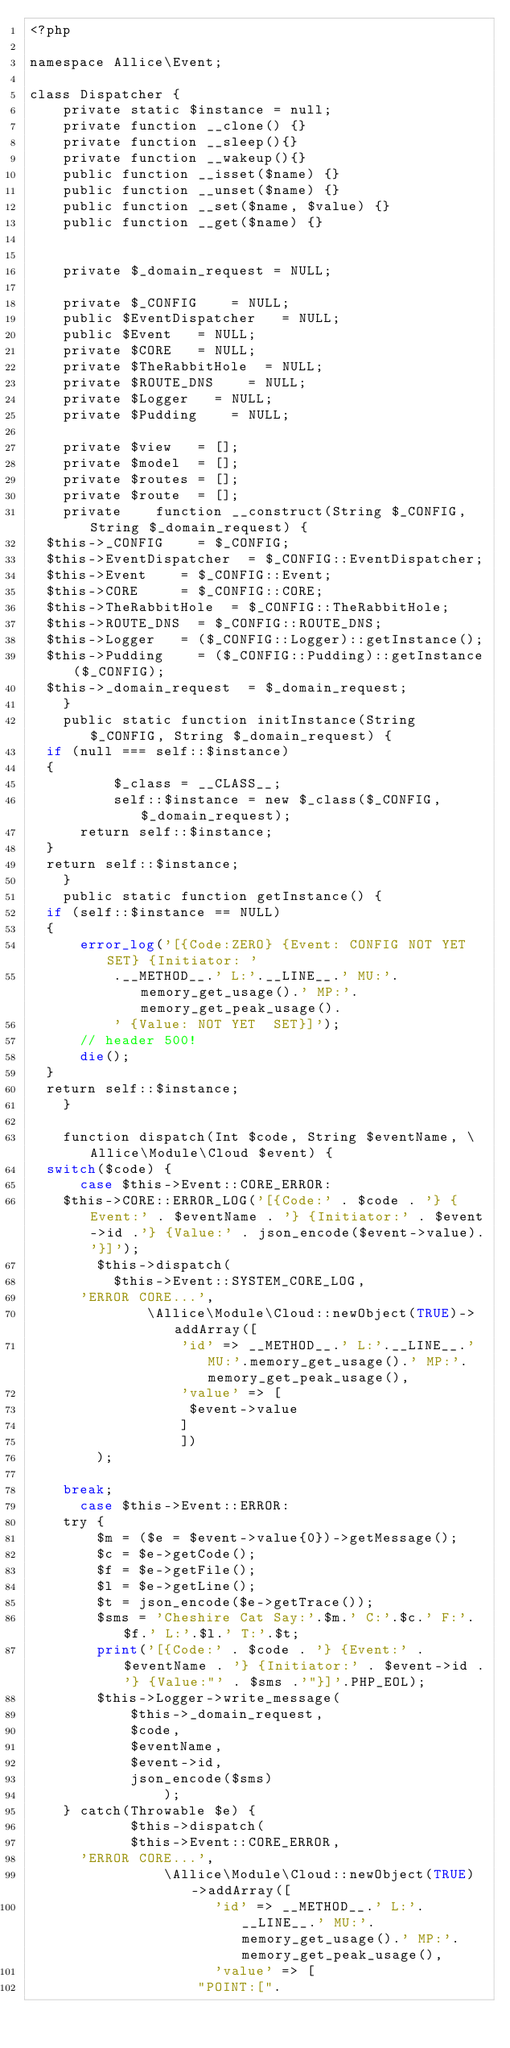<code> <loc_0><loc_0><loc_500><loc_500><_PHP_><?php

namespace Allice\Event;

class Dispatcher {
    private static $instance = null;
    private function __clone() {}
    private function __sleep(){}
    private function __wakeup(){}
    public function __isset($name) {}
    public function __unset($name) {}
    public function __set($name, $value) {}
    public function __get($name) {}
    

    private $_domain_request = NULL;
    
    private $_CONFIG		= NULL;
    public $EventDispatcher 	= NULL;
    public $Event		= NULL;
    private $CORE		= NULL;
    private $TheRabbitHole	= NULL;
    private $ROUTE_DNS		= NULL;
    private $Logger		= NULL;
    private $Pudding		= NULL;

    private $view   = [];
    private $model  = [];
    private $routes = [];
    private $route  = [];
    private    function __construct(String $_CONFIG, String $_domain_request) {
	$this->_CONFIG 		= $_CONFIG;
	$this->EventDispatcher 	= $_CONFIG::EventDispatcher;
	$this->Event		= $_CONFIG::Event;
	$this->CORE  		= $_CONFIG::CORE;
	$this->TheRabbitHole 	= $_CONFIG::TheRabbitHole;
	$this->ROUTE_DNS 	= $_CONFIG::ROUTE_DNS;
	$this->Logger		= ($_CONFIG::Logger)::getInstance();
	$this->Pudding		= ($_CONFIG::Pudding)::getInstance($_CONFIG);
	$this->_domain_request	= $_domain_request;
    }
    public static function initInstance(String $_CONFIG, String $_domain_request) {
	if (null === self::$instance)
	{
    	    $_class = __CLASS__;
    	    self::$instance = new $_class($_CONFIG, $_domain_request);
	    return self::$instance;
	}
	return self::$instance;
    }
    public static function getInstance() {
	if (self::$instance == NULL)
	{
	    error_log('[{Code:ZERO} {Event: CONFIG NOT YET SET} {Initiator: '
					.__METHOD__.' L:'.__LINE__.' MU:'.memory_get_usage().' MP:'.memory_get_peak_usage().
					' {Value: NOT YET  SET}]');
	    // header 500!
	    die(); 
	}
	return self::$instance;
    }

    function dispatch(Int $code, String $eventName, \Allice\Module\Cloud $event) { 
	switch($code) {
	    case $this->Event::CORE_ERROR:
		$this->CORE::ERROR_LOG('[{Code:' . $code . '} {Event:' . $eventName . '} {Initiator:' . $event->id .'} {Value:' . json_encode($event->value).'}]');
    		$this->dispatch(
	    		$this->Event::SYSTEM_CORE_LOG,
			'ERROR CORE...',
    	    		\Allice\Module\Cloud::newObject(TRUE)->addArray([
							    'id' => __METHOD__.' L:'.__LINE__.' MU:'.memory_get_usage().' MP:'.memory_get_peak_usage(),
							    'value' => [
									 $event->value
									]
	    						])
		    );
		
		break;
	    case $this->Event::ERROR:
		try {
		    $m = ($e = $event->value{0})->getMessage();
		    $c = $e->getCode();
		    $f = $e->getFile();
		    $l = $e->getLine();
		    $t = json_encode($e->getTrace());
		    $sms = 'Cheshire Cat Say:'.$m.' C:'.$c.' F:'.$f.' L:'.$l.' T:'.$t;
		    print('[{Code:' . $code . '} {Event:' . $eventName . '} {Initiator:' . $event->id .'} {Value:"' . $sms .'"}]'.PHP_EOL);
		    $this->Logger->write_message(
						$this->_domain_request,
						$code,
						$eventName,
						$event->id,
						json_encode($sms)
		    				); 
		} catch(Throwable $e) {
	    	    $this->dispatch(
		        $this->Event::CORE_ERROR,
			'ERROR CORE...',
	    	        \Allice\Module\Cloud::newObject(TRUE)->addArray([
		    	    				'id' => __METHOD__.' L:'.__LINE__.' MU:'.memory_get_usage().' MP:'.memory_get_peak_usage(),
		    	    				'value' => [
								    "POINT:[".</code> 